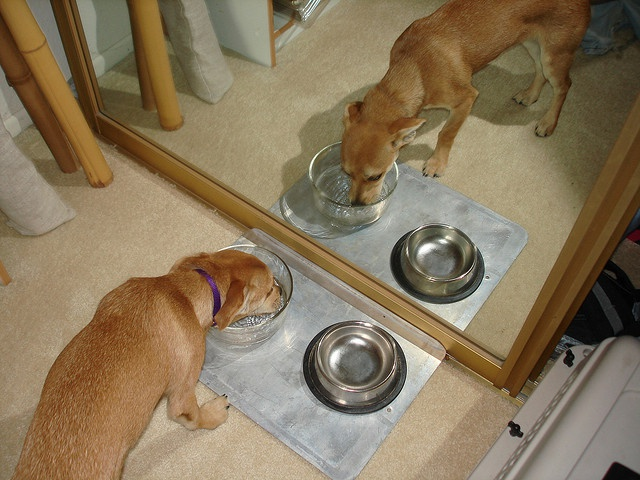Describe the objects in this image and their specific colors. I can see dog in maroon, brown, gray, and tan tones, dog in maroon and olive tones, bowl in maroon, gray, and olive tones, bowl in maroon, gray, darkgray, and black tones, and bowl in maroon, gray, darkgreen, black, and darkgray tones in this image. 